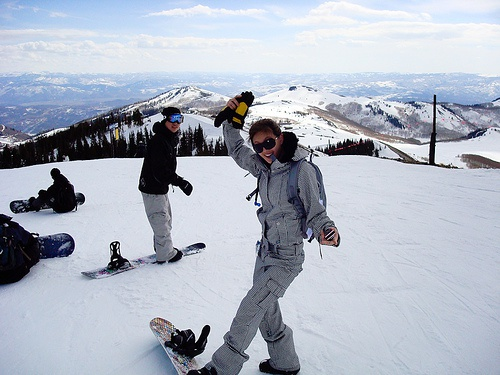Describe the objects in this image and their specific colors. I can see people in darkgray, gray, and black tones, people in darkgray, black, and gray tones, backpack in darkgray, black, gray, and navy tones, snowboard in darkgray, black, and gray tones, and people in darkgray, black, gray, and lavender tones in this image. 